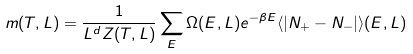<formula> <loc_0><loc_0><loc_500><loc_500>m ( T , L ) = \frac { 1 } { L ^ { d } Z ( T , L ) } \sum _ { E } \Omega ( E , L ) e ^ { - \beta E } \langle | N _ { + } - N _ { - } | \rangle ( E , L )</formula> 